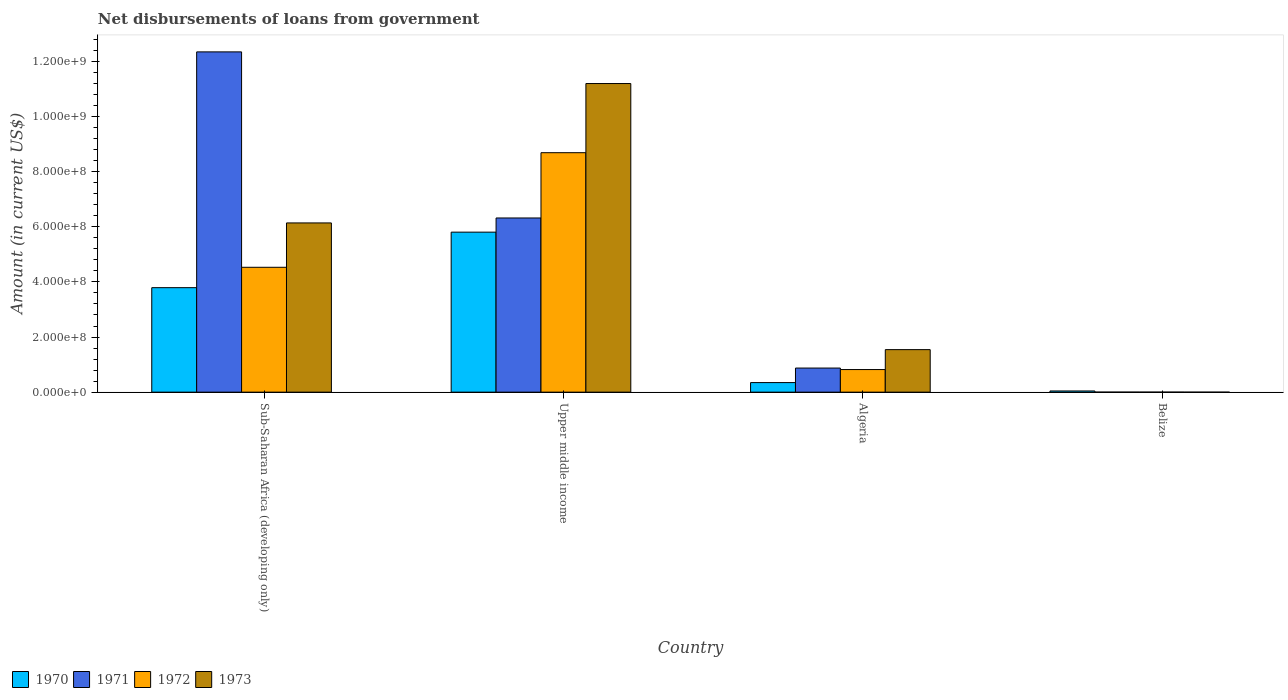Are the number of bars per tick equal to the number of legend labels?
Give a very brief answer. No. Are the number of bars on each tick of the X-axis equal?
Ensure brevity in your answer.  No. How many bars are there on the 3rd tick from the left?
Your answer should be very brief. 4. How many bars are there on the 2nd tick from the right?
Your response must be concise. 4. What is the label of the 1st group of bars from the left?
Offer a terse response. Sub-Saharan Africa (developing only). What is the amount of loan disbursed from government in 1970 in Upper middle income?
Provide a succinct answer. 5.81e+08. Across all countries, what is the maximum amount of loan disbursed from government in 1973?
Offer a terse response. 1.12e+09. Across all countries, what is the minimum amount of loan disbursed from government in 1973?
Provide a succinct answer. 0. In which country was the amount of loan disbursed from government in 1972 maximum?
Your answer should be compact. Upper middle income. What is the total amount of loan disbursed from government in 1970 in the graph?
Give a very brief answer. 9.99e+08. What is the difference between the amount of loan disbursed from government in 1972 in Sub-Saharan Africa (developing only) and that in Upper middle income?
Offer a terse response. -4.16e+08. What is the difference between the amount of loan disbursed from government in 1972 in Belize and the amount of loan disbursed from government in 1971 in Algeria?
Provide a succinct answer. -8.74e+07. What is the average amount of loan disbursed from government in 1973 per country?
Your response must be concise. 4.72e+08. What is the difference between the amount of loan disbursed from government of/in 1970 and amount of loan disbursed from government of/in 1972 in Upper middle income?
Offer a very short reply. -2.88e+08. In how many countries, is the amount of loan disbursed from government in 1972 greater than 960000000 US$?
Provide a succinct answer. 0. What is the ratio of the amount of loan disbursed from government in 1970 in Belize to that in Sub-Saharan Africa (developing only)?
Provide a succinct answer. 0.01. What is the difference between the highest and the second highest amount of loan disbursed from government in 1971?
Offer a terse response. 6.03e+08. What is the difference between the highest and the lowest amount of loan disbursed from government in 1972?
Ensure brevity in your answer.  8.69e+08. Is the sum of the amount of loan disbursed from government in 1971 in Sub-Saharan Africa (developing only) and Upper middle income greater than the maximum amount of loan disbursed from government in 1973 across all countries?
Keep it short and to the point. Yes. Is it the case that in every country, the sum of the amount of loan disbursed from government in 1972 and amount of loan disbursed from government in 1971 is greater than the amount of loan disbursed from government in 1970?
Your answer should be very brief. No. Are all the bars in the graph horizontal?
Your answer should be compact. No. Are the values on the major ticks of Y-axis written in scientific E-notation?
Give a very brief answer. Yes. Does the graph contain grids?
Make the answer very short. No. How many legend labels are there?
Your answer should be very brief. 4. What is the title of the graph?
Make the answer very short. Net disbursements of loans from government. What is the label or title of the X-axis?
Your answer should be very brief. Country. What is the label or title of the Y-axis?
Provide a succinct answer. Amount (in current US$). What is the Amount (in current US$) of 1970 in Sub-Saharan Africa (developing only)?
Ensure brevity in your answer.  3.79e+08. What is the Amount (in current US$) of 1971 in Sub-Saharan Africa (developing only)?
Keep it short and to the point. 1.23e+09. What is the Amount (in current US$) in 1972 in Sub-Saharan Africa (developing only)?
Offer a very short reply. 4.53e+08. What is the Amount (in current US$) in 1973 in Sub-Saharan Africa (developing only)?
Your response must be concise. 6.14e+08. What is the Amount (in current US$) in 1970 in Upper middle income?
Offer a very short reply. 5.81e+08. What is the Amount (in current US$) in 1971 in Upper middle income?
Provide a short and direct response. 6.32e+08. What is the Amount (in current US$) of 1972 in Upper middle income?
Provide a succinct answer. 8.69e+08. What is the Amount (in current US$) of 1973 in Upper middle income?
Provide a succinct answer. 1.12e+09. What is the Amount (in current US$) in 1970 in Algeria?
Give a very brief answer. 3.47e+07. What is the Amount (in current US$) of 1971 in Algeria?
Keep it short and to the point. 8.74e+07. What is the Amount (in current US$) of 1972 in Algeria?
Your response must be concise. 8.20e+07. What is the Amount (in current US$) in 1973 in Algeria?
Ensure brevity in your answer.  1.54e+08. What is the Amount (in current US$) of 1970 in Belize?
Provide a succinct answer. 4.30e+06. What is the Amount (in current US$) of 1971 in Belize?
Give a very brief answer. 0. Across all countries, what is the maximum Amount (in current US$) in 1970?
Ensure brevity in your answer.  5.81e+08. Across all countries, what is the maximum Amount (in current US$) of 1971?
Ensure brevity in your answer.  1.23e+09. Across all countries, what is the maximum Amount (in current US$) of 1972?
Your answer should be compact. 8.69e+08. Across all countries, what is the maximum Amount (in current US$) of 1973?
Keep it short and to the point. 1.12e+09. Across all countries, what is the minimum Amount (in current US$) in 1970?
Provide a succinct answer. 4.30e+06. Across all countries, what is the minimum Amount (in current US$) in 1971?
Provide a succinct answer. 0. Across all countries, what is the minimum Amount (in current US$) in 1972?
Your response must be concise. 0. What is the total Amount (in current US$) in 1970 in the graph?
Offer a terse response. 9.99e+08. What is the total Amount (in current US$) of 1971 in the graph?
Ensure brevity in your answer.  1.95e+09. What is the total Amount (in current US$) in 1972 in the graph?
Give a very brief answer. 1.40e+09. What is the total Amount (in current US$) of 1973 in the graph?
Your answer should be very brief. 1.89e+09. What is the difference between the Amount (in current US$) of 1970 in Sub-Saharan Africa (developing only) and that in Upper middle income?
Give a very brief answer. -2.01e+08. What is the difference between the Amount (in current US$) of 1971 in Sub-Saharan Africa (developing only) and that in Upper middle income?
Your response must be concise. 6.03e+08. What is the difference between the Amount (in current US$) of 1972 in Sub-Saharan Africa (developing only) and that in Upper middle income?
Offer a very short reply. -4.16e+08. What is the difference between the Amount (in current US$) of 1973 in Sub-Saharan Africa (developing only) and that in Upper middle income?
Provide a succinct answer. -5.06e+08. What is the difference between the Amount (in current US$) of 1970 in Sub-Saharan Africa (developing only) and that in Algeria?
Your response must be concise. 3.44e+08. What is the difference between the Amount (in current US$) of 1971 in Sub-Saharan Africa (developing only) and that in Algeria?
Give a very brief answer. 1.15e+09. What is the difference between the Amount (in current US$) of 1972 in Sub-Saharan Africa (developing only) and that in Algeria?
Your answer should be compact. 3.71e+08. What is the difference between the Amount (in current US$) in 1973 in Sub-Saharan Africa (developing only) and that in Algeria?
Your answer should be very brief. 4.60e+08. What is the difference between the Amount (in current US$) in 1970 in Sub-Saharan Africa (developing only) and that in Belize?
Keep it short and to the point. 3.75e+08. What is the difference between the Amount (in current US$) in 1970 in Upper middle income and that in Algeria?
Your response must be concise. 5.46e+08. What is the difference between the Amount (in current US$) in 1971 in Upper middle income and that in Algeria?
Offer a terse response. 5.45e+08. What is the difference between the Amount (in current US$) in 1972 in Upper middle income and that in Algeria?
Your response must be concise. 7.87e+08. What is the difference between the Amount (in current US$) of 1973 in Upper middle income and that in Algeria?
Your answer should be very brief. 9.66e+08. What is the difference between the Amount (in current US$) of 1970 in Upper middle income and that in Belize?
Your response must be concise. 5.76e+08. What is the difference between the Amount (in current US$) of 1970 in Algeria and that in Belize?
Keep it short and to the point. 3.04e+07. What is the difference between the Amount (in current US$) of 1970 in Sub-Saharan Africa (developing only) and the Amount (in current US$) of 1971 in Upper middle income?
Give a very brief answer. -2.53e+08. What is the difference between the Amount (in current US$) in 1970 in Sub-Saharan Africa (developing only) and the Amount (in current US$) in 1972 in Upper middle income?
Give a very brief answer. -4.90e+08. What is the difference between the Amount (in current US$) of 1970 in Sub-Saharan Africa (developing only) and the Amount (in current US$) of 1973 in Upper middle income?
Make the answer very short. -7.41e+08. What is the difference between the Amount (in current US$) of 1971 in Sub-Saharan Africa (developing only) and the Amount (in current US$) of 1972 in Upper middle income?
Give a very brief answer. 3.66e+08. What is the difference between the Amount (in current US$) of 1971 in Sub-Saharan Africa (developing only) and the Amount (in current US$) of 1973 in Upper middle income?
Provide a short and direct response. 1.15e+08. What is the difference between the Amount (in current US$) of 1972 in Sub-Saharan Africa (developing only) and the Amount (in current US$) of 1973 in Upper middle income?
Your answer should be very brief. -6.67e+08. What is the difference between the Amount (in current US$) of 1970 in Sub-Saharan Africa (developing only) and the Amount (in current US$) of 1971 in Algeria?
Provide a succinct answer. 2.92e+08. What is the difference between the Amount (in current US$) of 1970 in Sub-Saharan Africa (developing only) and the Amount (in current US$) of 1972 in Algeria?
Keep it short and to the point. 2.97e+08. What is the difference between the Amount (in current US$) of 1970 in Sub-Saharan Africa (developing only) and the Amount (in current US$) of 1973 in Algeria?
Your answer should be very brief. 2.25e+08. What is the difference between the Amount (in current US$) in 1971 in Sub-Saharan Africa (developing only) and the Amount (in current US$) in 1972 in Algeria?
Make the answer very short. 1.15e+09. What is the difference between the Amount (in current US$) in 1971 in Sub-Saharan Africa (developing only) and the Amount (in current US$) in 1973 in Algeria?
Offer a very short reply. 1.08e+09. What is the difference between the Amount (in current US$) of 1972 in Sub-Saharan Africa (developing only) and the Amount (in current US$) of 1973 in Algeria?
Offer a terse response. 2.99e+08. What is the difference between the Amount (in current US$) of 1970 in Upper middle income and the Amount (in current US$) of 1971 in Algeria?
Offer a very short reply. 4.93e+08. What is the difference between the Amount (in current US$) of 1970 in Upper middle income and the Amount (in current US$) of 1972 in Algeria?
Make the answer very short. 4.99e+08. What is the difference between the Amount (in current US$) of 1970 in Upper middle income and the Amount (in current US$) of 1973 in Algeria?
Keep it short and to the point. 4.26e+08. What is the difference between the Amount (in current US$) of 1971 in Upper middle income and the Amount (in current US$) of 1972 in Algeria?
Provide a short and direct response. 5.50e+08. What is the difference between the Amount (in current US$) of 1971 in Upper middle income and the Amount (in current US$) of 1973 in Algeria?
Your response must be concise. 4.78e+08. What is the difference between the Amount (in current US$) of 1972 in Upper middle income and the Amount (in current US$) of 1973 in Algeria?
Provide a succinct answer. 7.15e+08. What is the average Amount (in current US$) in 1970 per country?
Offer a very short reply. 2.50e+08. What is the average Amount (in current US$) in 1971 per country?
Make the answer very short. 4.89e+08. What is the average Amount (in current US$) in 1972 per country?
Your answer should be very brief. 3.51e+08. What is the average Amount (in current US$) of 1973 per country?
Your response must be concise. 4.72e+08. What is the difference between the Amount (in current US$) in 1970 and Amount (in current US$) in 1971 in Sub-Saharan Africa (developing only)?
Ensure brevity in your answer.  -8.56e+08. What is the difference between the Amount (in current US$) of 1970 and Amount (in current US$) of 1972 in Sub-Saharan Africa (developing only)?
Provide a succinct answer. -7.40e+07. What is the difference between the Amount (in current US$) in 1970 and Amount (in current US$) in 1973 in Sub-Saharan Africa (developing only)?
Offer a very short reply. -2.35e+08. What is the difference between the Amount (in current US$) in 1971 and Amount (in current US$) in 1972 in Sub-Saharan Africa (developing only)?
Keep it short and to the point. 7.82e+08. What is the difference between the Amount (in current US$) in 1971 and Amount (in current US$) in 1973 in Sub-Saharan Africa (developing only)?
Keep it short and to the point. 6.21e+08. What is the difference between the Amount (in current US$) in 1972 and Amount (in current US$) in 1973 in Sub-Saharan Africa (developing only)?
Offer a very short reply. -1.61e+08. What is the difference between the Amount (in current US$) in 1970 and Amount (in current US$) in 1971 in Upper middle income?
Provide a short and direct response. -5.14e+07. What is the difference between the Amount (in current US$) of 1970 and Amount (in current US$) of 1972 in Upper middle income?
Provide a succinct answer. -2.88e+08. What is the difference between the Amount (in current US$) of 1970 and Amount (in current US$) of 1973 in Upper middle income?
Offer a terse response. -5.39e+08. What is the difference between the Amount (in current US$) in 1971 and Amount (in current US$) in 1972 in Upper middle income?
Make the answer very short. -2.37e+08. What is the difference between the Amount (in current US$) of 1971 and Amount (in current US$) of 1973 in Upper middle income?
Give a very brief answer. -4.88e+08. What is the difference between the Amount (in current US$) in 1972 and Amount (in current US$) in 1973 in Upper middle income?
Keep it short and to the point. -2.51e+08. What is the difference between the Amount (in current US$) of 1970 and Amount (in current US$) of 1971 in Algeria?
Ensure brevity in your answer.  -5.27e+07. What is the difference between the Amount (in current US$) in 1970 and Amount (in current US$) in 1972 in Algeria?
Provide a short and direct response. -4.73e+07. What is the difference between the Amount (in current US$) in 1970 and Amount (in current US$) in 1973 in Algeria?
Keep it short and to the point. -1.20e+08. What is the difference between the Amount (in current US$) of 1971 and Amount (in current US$) of 1972 in Algeria?
Provide a succinct answer. 5.44e+06. What is the difference between the Amount (in current US$) in 1971 and Amount (in current US$) in 1973 in Algeria?
Offer a terse response. -6.69e+07. What is the difference between the Amount (in current US$) of 1972 and Amount (in current US$) of 1973 in Algeria?
Your answer should be very brief. -7.23e+07. What is the ratio of the Amount (in current US$) of 1970 in Sub-Saharan Africa (developing only) to that in Upper middle income?
Your response must be concise. 0.65. What is the ratio of the Amount (in current US$) of 1971 in Sub-Saharan Africa (developing only) to that in Upper middle income?
Give a very brief answer. 1.95. What is the ratio of the Amount (in current US$) in 1972 in Sub-Saharan Africa (developing only) to that in Upper middle income?
Your response must be concise. 0.52. What is the ratio of the Amount (in current US$) in 1973 in Sub-Saharan Africa (developing only) to that in Upper middle income?
Provide a succinct answer. 0.55. What is the ratio of the Amount (in current US$) of 1970 in Sub-Saharan Africa (developing only) to that in Algeria?
Your answer should be very brief. 10.92. What is the ratio of the Amount (in current US$) in 1971 in Sub-Saharan Africa (developing only) to that in Algeria?
Offer a very short reply. 14.12. What is the ratio of the Amount (in current US$) in 1972 in Sub-Saharan Africa (developing only) to that in Algeria?
Give a very brief answer. 5.53. What is the ratio of the Amount (in current US$) of 1973 in Sub-Saharan Africa (developing only) to that in Algeria?
Provide a short and direct response. 3.98. What is the ratio of the Amount (in current US$) of 1970 in Sub-Saharan Africa (developing only) to that in Belize?
Offer a very short reply. 88.16. What is the ratio of the Amount (in current US$) in 1970 in Upper middle income to that in Algeria?
Keep it short and to the point. 16.73. What is the ratio of the Amount (in current US$) in 1971 in Upper middle income to that in Algeria?
Ensure brevity in your answer.  7.23. What is the ratio of the Amount (in current US$) in 1972 in Upper middle income to that in Algeria?
Offer a very short reply. 10.6. What is the ratio of the Amount (in current US$) of 1973 in Upper middle income to that in Algeria?
Your answer should be very brief. 7.26. What is the ratio of the Amount (in current US$) of 1970 in Upper middle income to that in Belize?
Offer a very short reply. 135.01. What is the ratio of the Amount (in current US$) of 1970 in Algeria to that in Belize?
Keep it short and to the point. 8.07. What is the difference between the highest and the second highest Amount (in current US$) in 1970?
Offer a very short reply. 2.01e+08. What is the difference between the highest and the second highest Amount (in current US$) of 1971?
Your answer should be compact. 6.03e+08. What is the difference between the highest and the second highest Amount (in current US$) in 1972?
Provide a succinct answer. 4.16e+08. What is the difference between the highest and the second highest Amount (in current US$) in 1973?
Your answer should be very brief. 5.06e+08. What is the difference between the highest and the lowest Amount (in current US$) in 1970?
Offer a terse response. 5.76e+08. What is the difference between the highest and the lowest Amount (in current US$) of 1971?
Provide a short and direct response. 1.23e+09. What is the difference between the highest and the lowest Amount (in current US$) of 1972?
Give a very brief answer. 8.69e+08. What is the difference between the highest and the lowest Amount (in current US$) in 1973?
Your answer should be compact. 1.12e+09. 